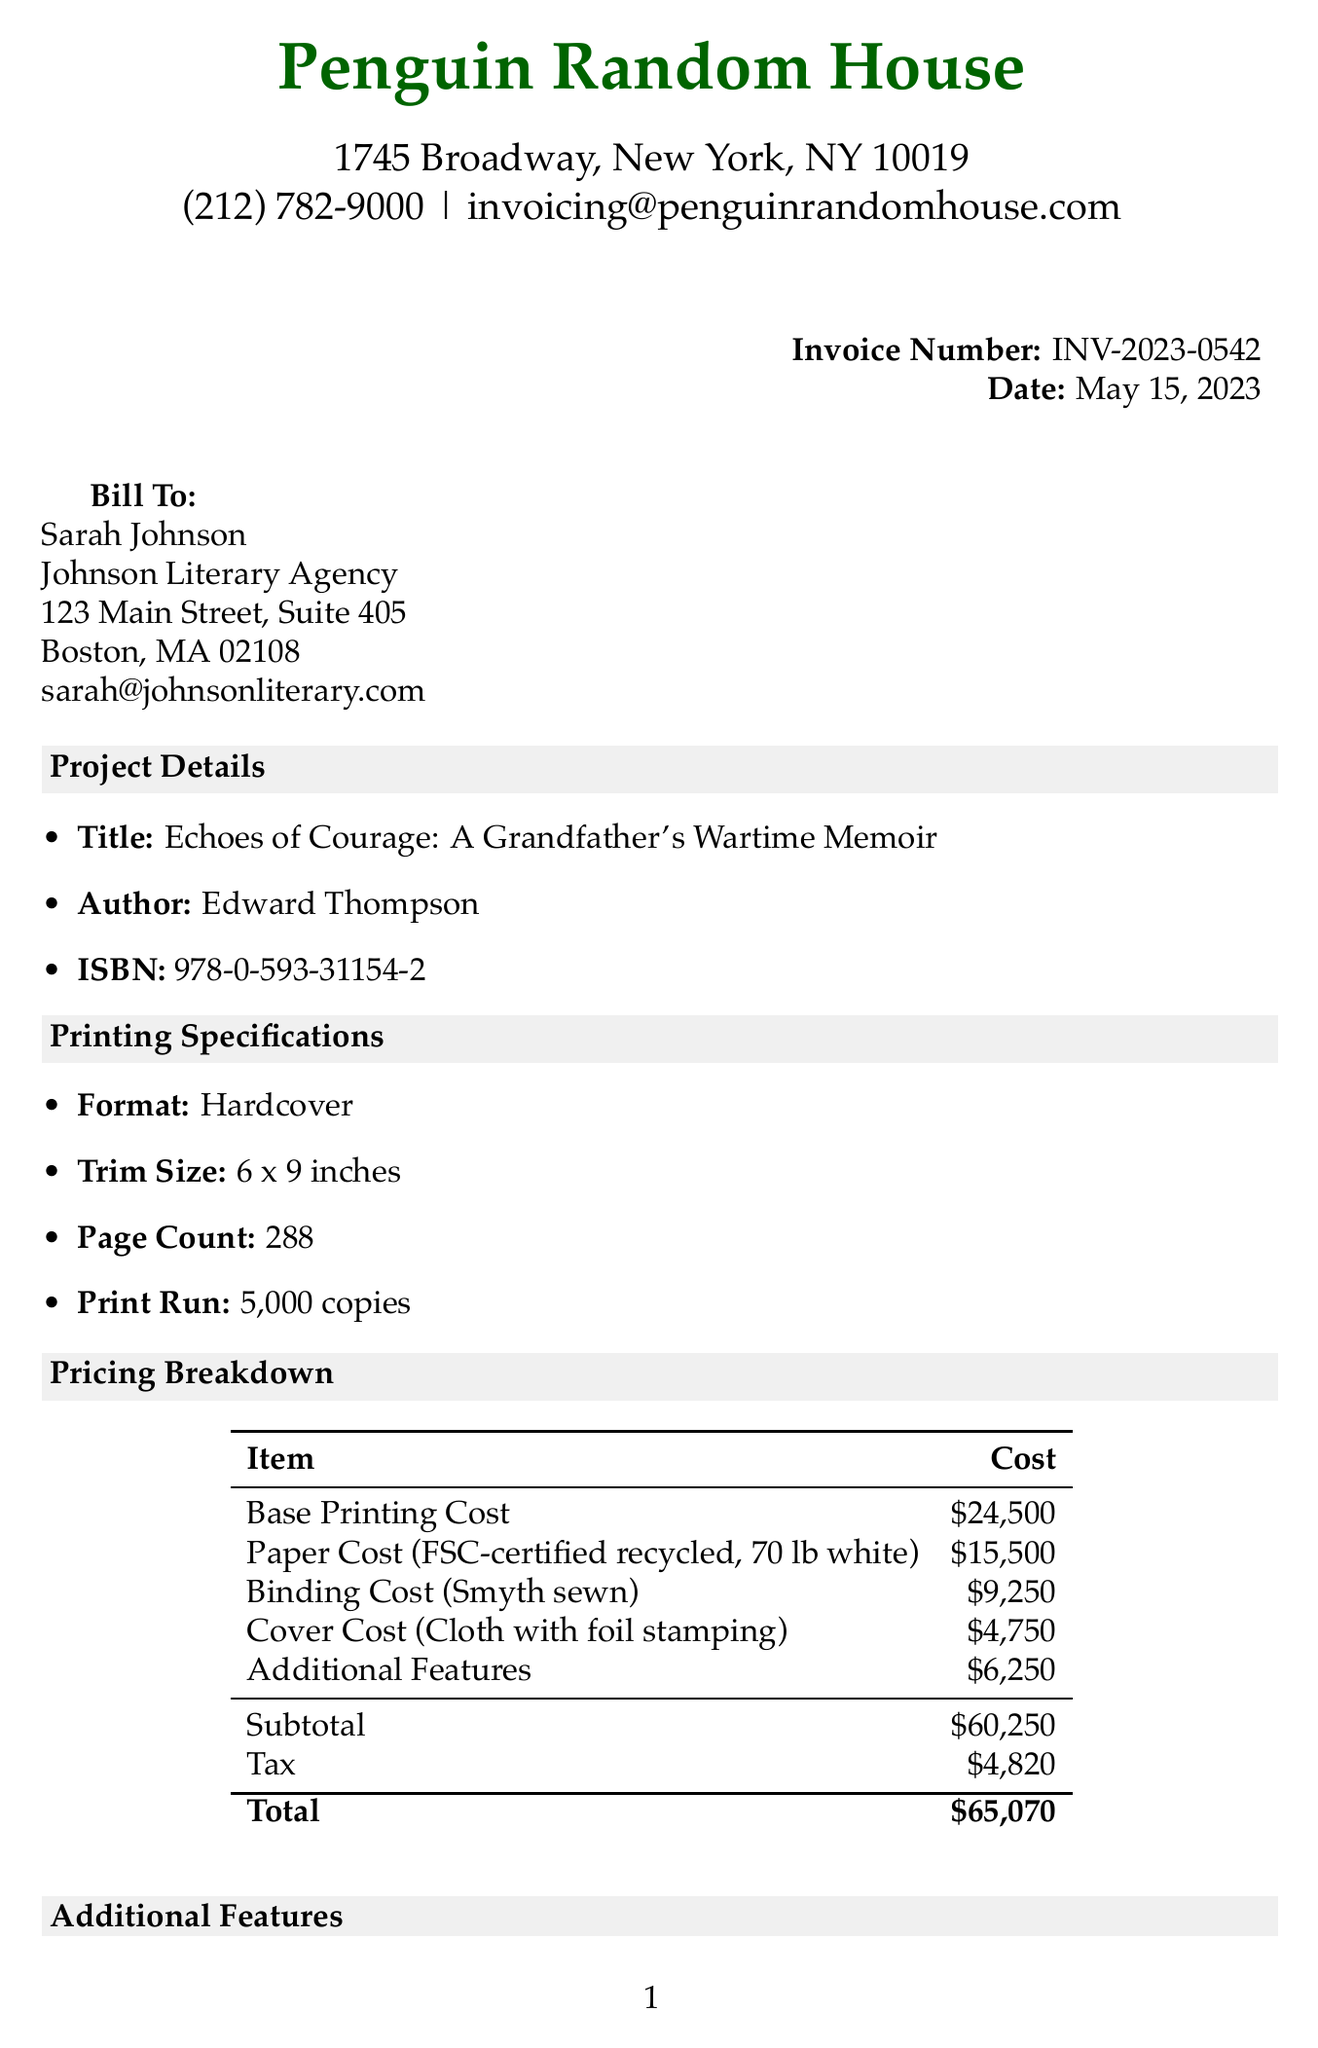what is the invoice number? The invoice number is explicitly stated in the document as INV-2023-0542.
Answer: INV-2023-0542 who is the author of the memoir? The document specifies the author of the memoir as Edward Thompson.
Answer: Edward Thompson what is the trim size of the book? The trim size is provided in the document as 6 x 9 inches.
Answer: 6 x 9 inches how many copies are printed in the print run? The document states that the print run includes 5000 copies.
Answer: 5000 what is the total cost for the project? The total cost is calculated and provided in the pricing section as $65,070.
Answer: $65,070 which binding option is described as durable and allows the book to lay flat? The document mentions Smyth sewn binding as the option that is durable and allows the book to lay flat when open.
Answer: Smyth sewn binding what percentage of the deposit is due upon approval of proof? The document indicates that a 50% deposit is due upon proof approval.
Answer: 50% what is the estimated completion time from proof approval? The estimated completion time is stated as 8-10 weeks from proof approval.
Answer: 8-10 weeks how much does the dust jacket cost? The document lists the cost of the dust jacket as $3,750.
Answer: $3,750 